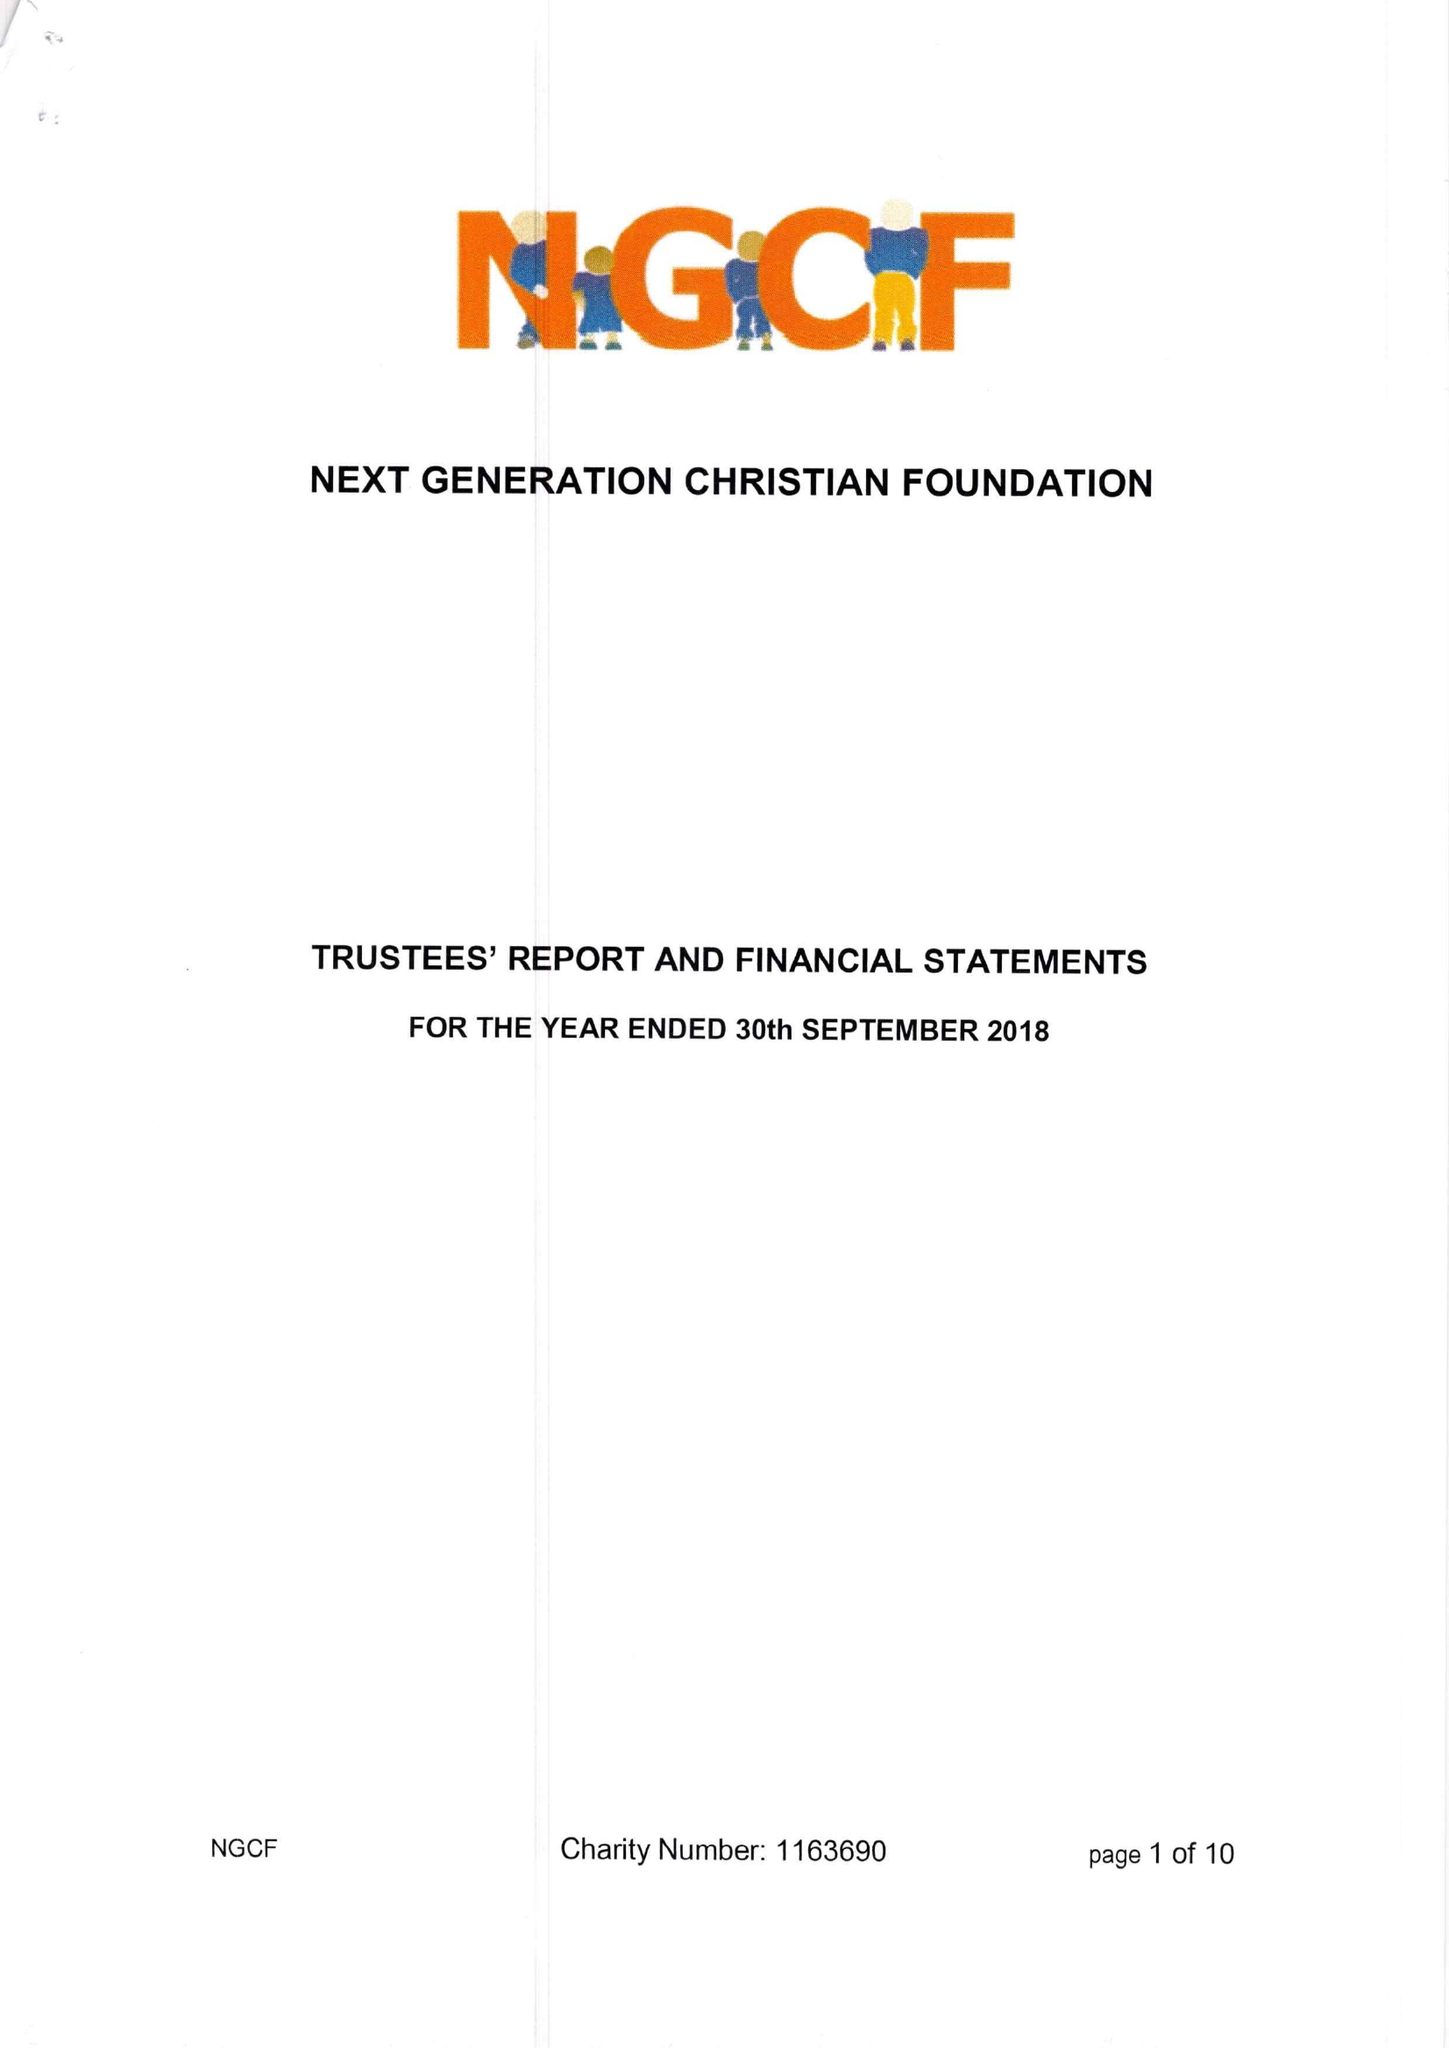What is the value for the charity_name?
Answer the question using a single word or phrase. Next Generation Christian Foundation 